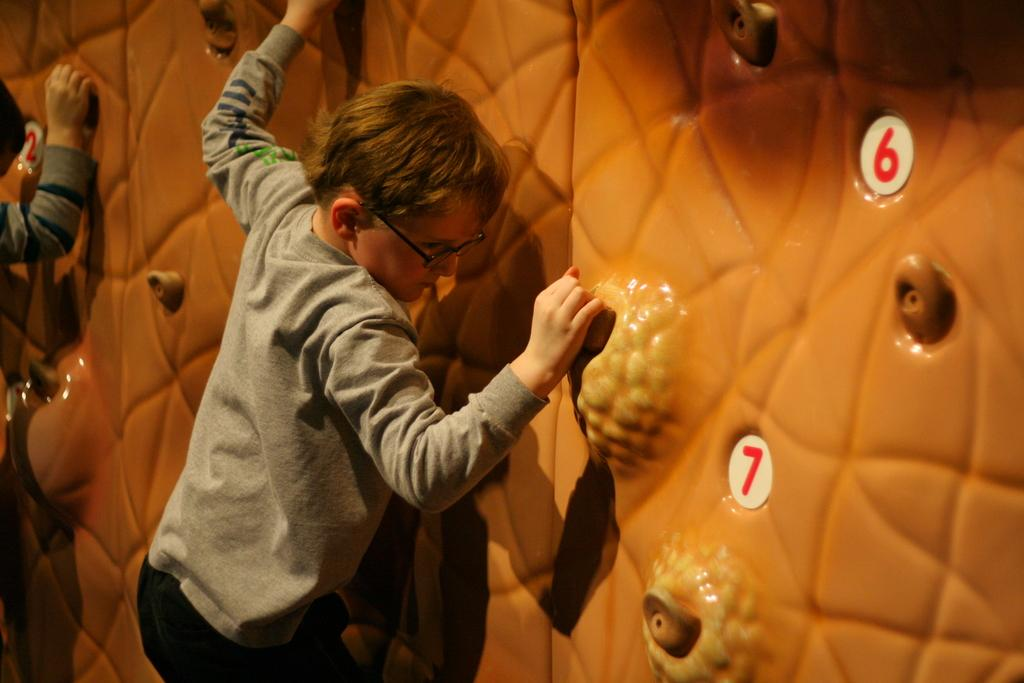What is the main subject of the image? There is a person in the image. What activity is the person engaged in? The person is climbing a wall, as there is a climbing wall in the image. Can you describe the other person visible in the image? There is another person on the left side of the image, but they are truncated, meaning only part of their body is visible. What type of grain can be seen growing near the climbing wall in the image? There is no grain visible in the image; it features a person climbing a wall and another person on the left side. 